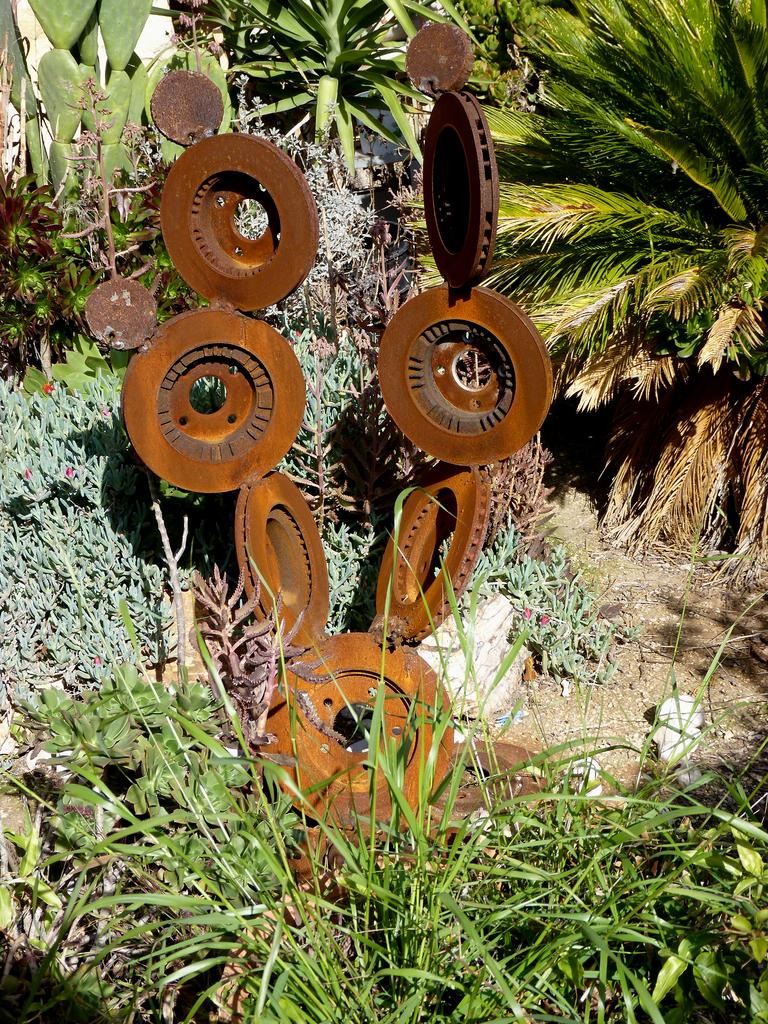What type of sculpture is in the image? There is a metal sculpture in the image. Where is the metal sculpture located? The metal sculpture is on the land. What type of vegetation can be seen in the image? There are plants, grass, and trees in the image. Can you see a horse standing next to the metal sculpture in the image? No, there is no horse present in the image. 